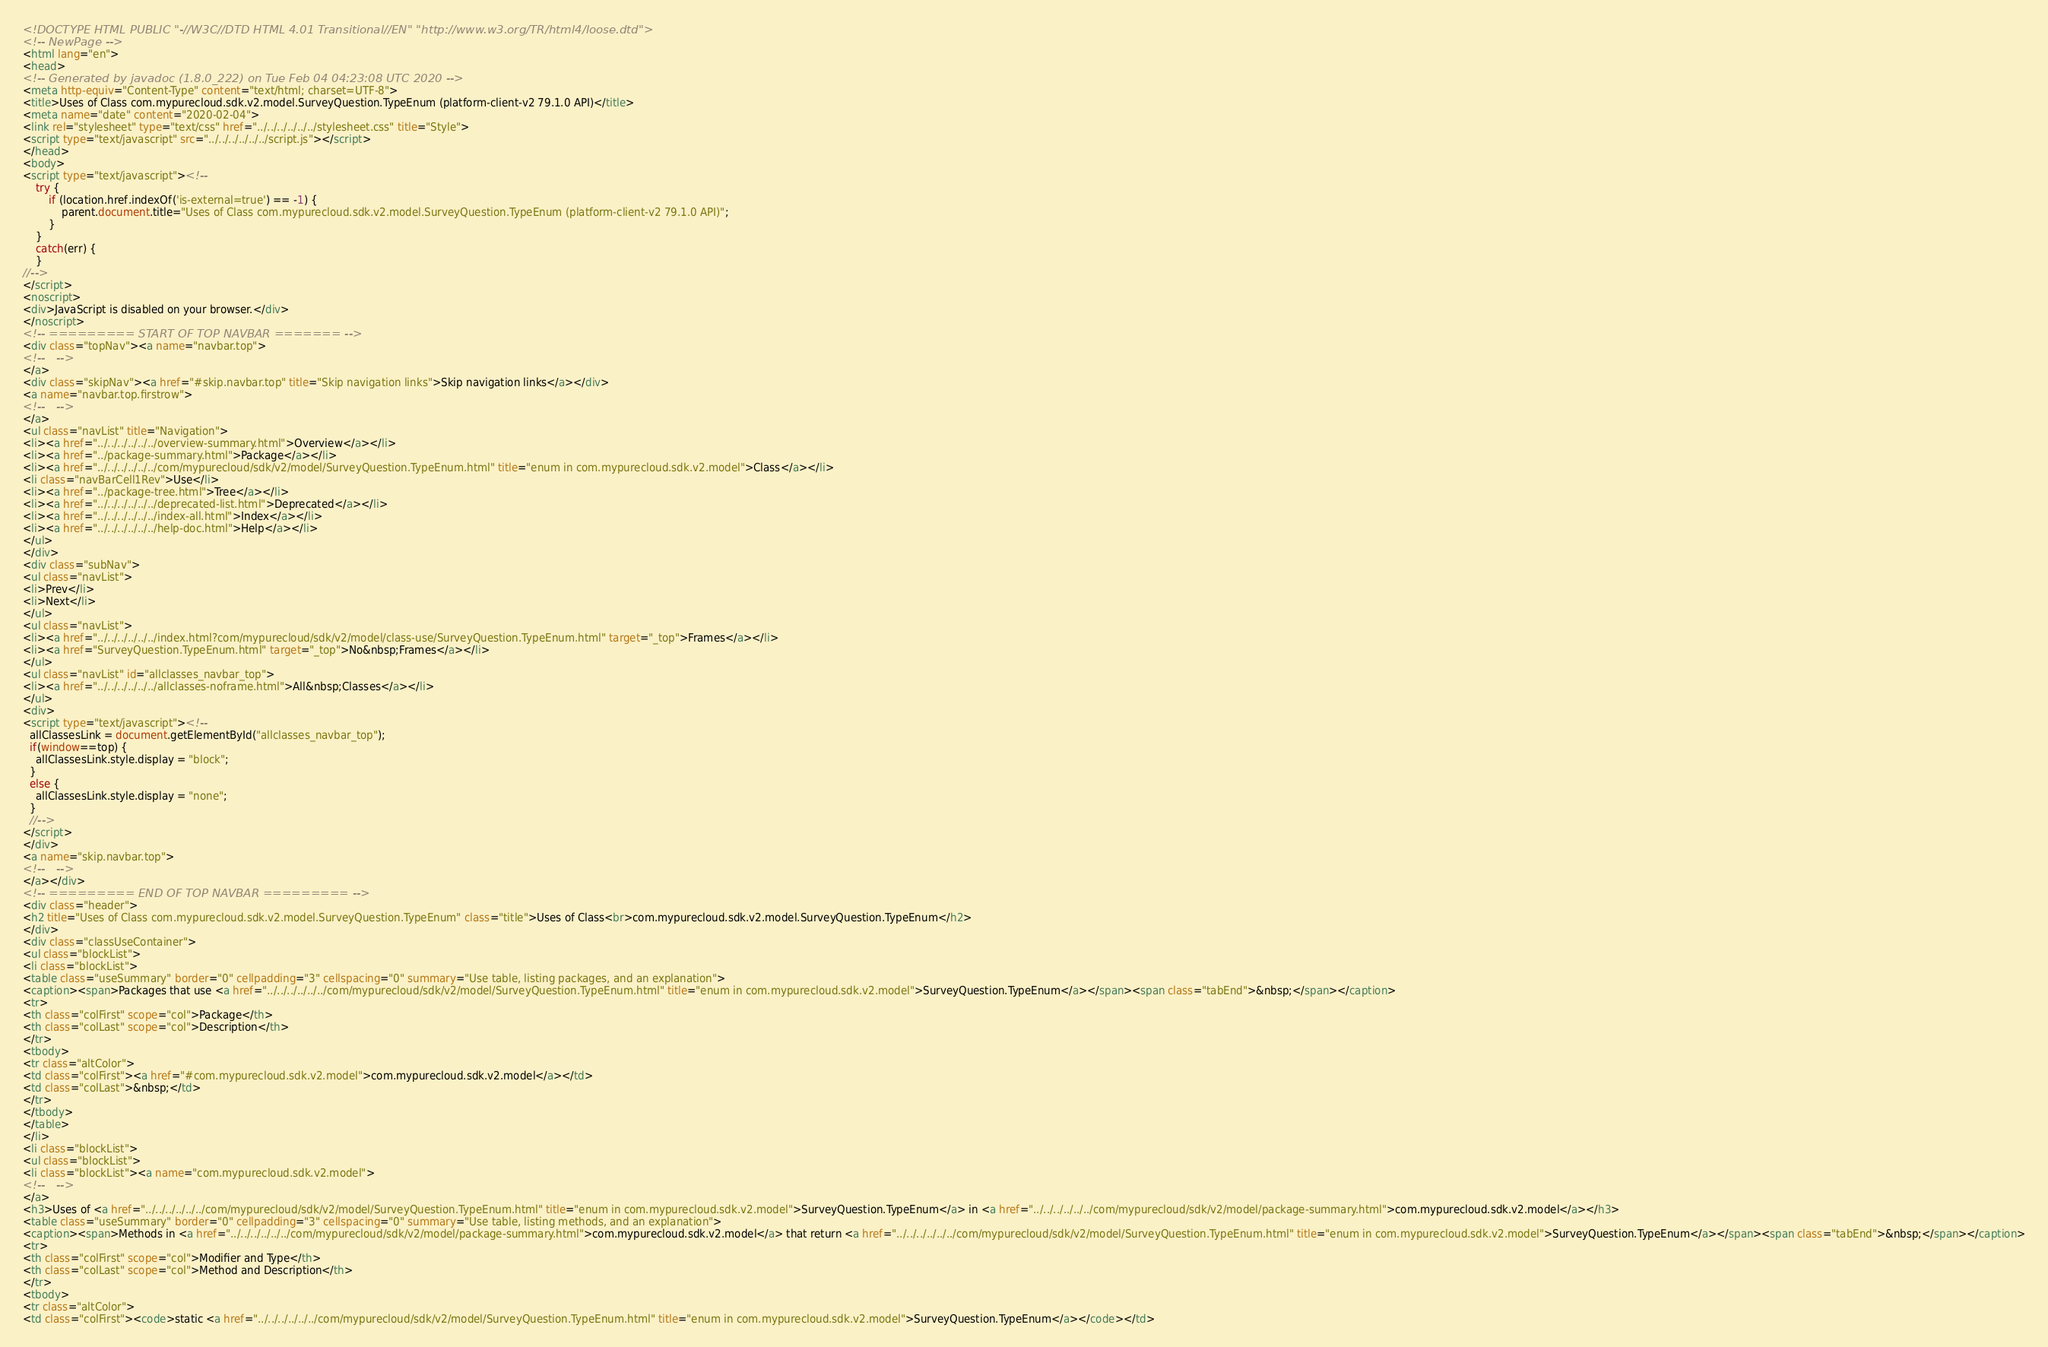<code> <loc_0><loc_0><loc_500><loc_500><_HTML_><!DOCTYPE HTML PUBLIC "-//W3C//DTD HTML 4.01 Transitional//EN" "http://www.w3.org/TR/html4/loose.dtd">
<!-- NewPage -->
<html lang="en">
<head>
<!-- Generated by javadoc (1.8.0_222) on Tue Feb 04 04:23:08 UTC 2020 -->
<meta http-equiv="Content-Type" content="text/html; charset=UTF-8">
<title>Uses of Class com.mypurecloud.sdk.v2.model.SurveyQuestion.TypeEnum (platform-client-v2 79.1.0 API)</title>
<meta name="date" content="2020-02-04">
<link rel="stylesheet" type="text/css" href="../../../../../../stylesheet.css" title="Style">
<script type="text/javascript" src="../../../../../../script.js"></script>
</head>
<body>
<script type="text/javascript"><!--
    try {
        if (location.href.indexOf('is-external=true') == -1) {
            parent.document.title="Uses of Class com.mypurecloud.sdk.v2.model.SurveyQuestion.TypeEnum (platform-client-v2 79.1.0 API)";
        }
    }
    catch(err) {
    }
//-->
</script>
<noscript>
<div>JavaScript is disabled on your browser.</div>
</noscript>
<!-- ========= START OF TOP NAVBAR ======= -->
<div class="topNav"><a name="navbar.top">
<!--   -->
</a>
<div class="skipNav"><a href="#skip.navbar.top" title="Skip navigation links">Skip navigation links</a></div>
<a name="navbar.top.firstrow">
<!--   -->
</a>
<ul class="navList" title="Navigation">
<li><a href="../../../../../../overview-summary.html">Overview</a></li>
<li><a href="../package-summary.html">Package</a></li>
<li><a href="../../../../../../com/mypurecloud/sdk/v2/model/SurveyQuestion.TypeEnum.html" title="enum in com.mypurecloud.sdk.v2.model">Class</a></li>
<li class="navBarCell1Rev">Use</li>
<li><a href="../package-tree.html">Tree</a></li>
<li><a href="../../../../../../deprecated-list.html">Deprecated</a></li>
<li><a href="../../../../../../index-all.html">Index</a></li>
<li><a href="../../../../../../help-doc.html">Help</a></li>
</ul>
</div>
<div class="subNav">
<ul class="navList">
<li>Prev</li>
<li>Next</li>
</ul>
<ul class="navList">
<li><a href="../../../../../../index.html?com/mypurecloud/sdk/v2/model/class-use/SurveyQuestion.TypeEnum.html" target="_top">Frames</a></li>
<li><a href="SurveyQuestion.TypeEnum.html" target="_top">No&nbsp;Frames</a></li>
</ul>
<ul class="navList" id="allclasses_navbar_top">
<li><a href="../../../../../../allclasses-noframe.html">All&nbsp;Classes</a></li>
</ul>
<div>
<script type="text/javascript"><!--
  allClassesLink = document.getElementById("allclasses_navbar_top");
  if(window==top) {
    allClassesLink.style.display = "block";
  }
  else {
    allClassesLink.style.display = "none";
  }
  //-->
</script>
</div>
<a name="skip.navbar.top">
<!--   -->
</a></div>
<!-- ========= END OF TOP NAVBAR ========= -->
<div class="header">
<h2 title="Uses of Class com.mypurecloud.sdk.v2.model.SurveyQuestion.TypeEnum" class="title">Uses of Class<br>com.mypurecloud.sdk.v2.model.SurveyQuestion.TypeEnum</h2>
</div>
<div class="classUseContainer">
<ul class="blockList">
<li class="blockList">
<table class="useSummary" border="0" cellpadding="3" cellspacing="0" summary="Use table, listing packages, and an explanation">
<caption><span>Packages that use <a href="../../../../../../com/mypurecloud/sdk/v2/model/SurveyQuestion.TypeEnum.html" title="enum in com.mypurecloud.sdk.v2.model">SurveyQuestion.TypeEnum</a></span><span class="tabEnd">&nbsp;</span></caption>
<tr>
<th class="colFirst" scope="col">Package</th>
<th class="colLast" scope="col">Description</th>
</tr>
<tbody>
<tr class="altColor">
<td class="colFirst"><a href="#com.mypurecloud.sdk.v2.model">com.mypurecloud.sdk.v2.model</a></td>
<td class="colLast">&nbsp;</td>
</tr>
</tbody>
</table>
</li>
<li class="blockList">
<ul class="blockList">
<li class="blockList"><a name="com.mypurecloud.sdk.v2.model">
<!--   -->
</a>
<h3>Uses of <a href="../../../../../../com/mypurecloud/sdk/v2/model/SurveyQuestion.TypeEnum.html" title="enum in com.mypurecloud.sdk.v2.model">SurveyQuestion.TypeEnum</a> in <a href="../../../../../../com/mypurecloud/sdk/v2/model/package-summary.html">com.mypurecloud.sdk.v2.model</a></h3>
<table class="useSummary" border="0" cellpadding="3" cellspacing="0" summary="Use table, listing methods, and an explanation">
<caption><span>Methods in <a href="../../../../../../com/mypurecloud/sdk/v2/model/package-summary.html">com.mypurecloud.sdk.v2.model</a> that return <a href="../../../../../../com/mypurecloud/sdk/v2/model/SurveyQuestion.TypeEnum.html" title="enum in com.mypurecloud.sdk.v2.model">SurveyQuestion.TypeEnum</a></span><span class="tabEnd">&nbsp;</span></caption>
<tr>
<th class="colFirst" scope="col">Modifier and Type</th>
<th class="colLast" scope="col">Method and Description</th>
</tr>
<tbody>
<tr class="altColor">
<td class="colFirst"><code>static <a href="../../../../../../com/mypurecloud/sdk/v2/model/SurveyQuestion.TypeEnum.html" title="enum in com.mypurecloud.sdk.v2.model">SurveyQuestion.TypeEnum</a></code></td></code> 